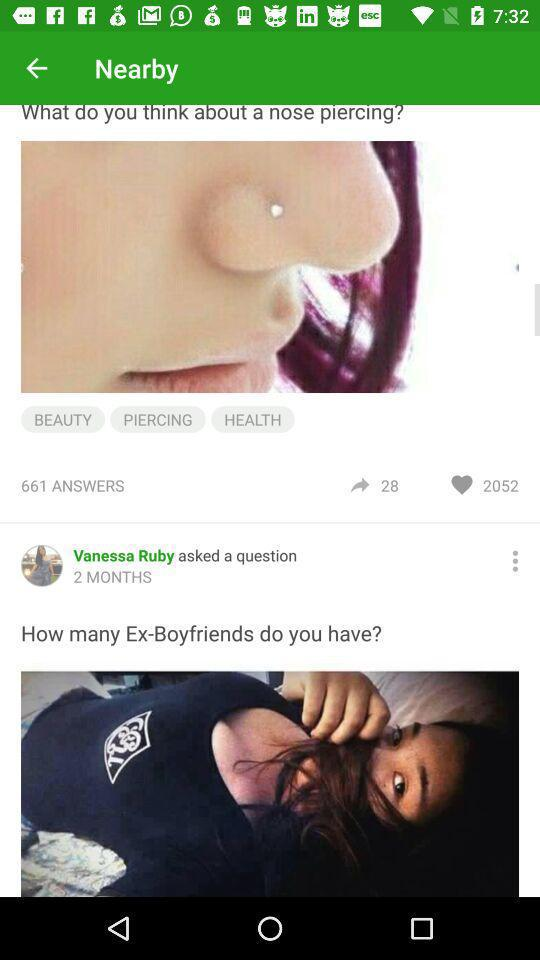How many likes are there to the question "What do you think about a nose piercing?"? There are 2052 likes to the question "What do you think about a nose piercing?". 